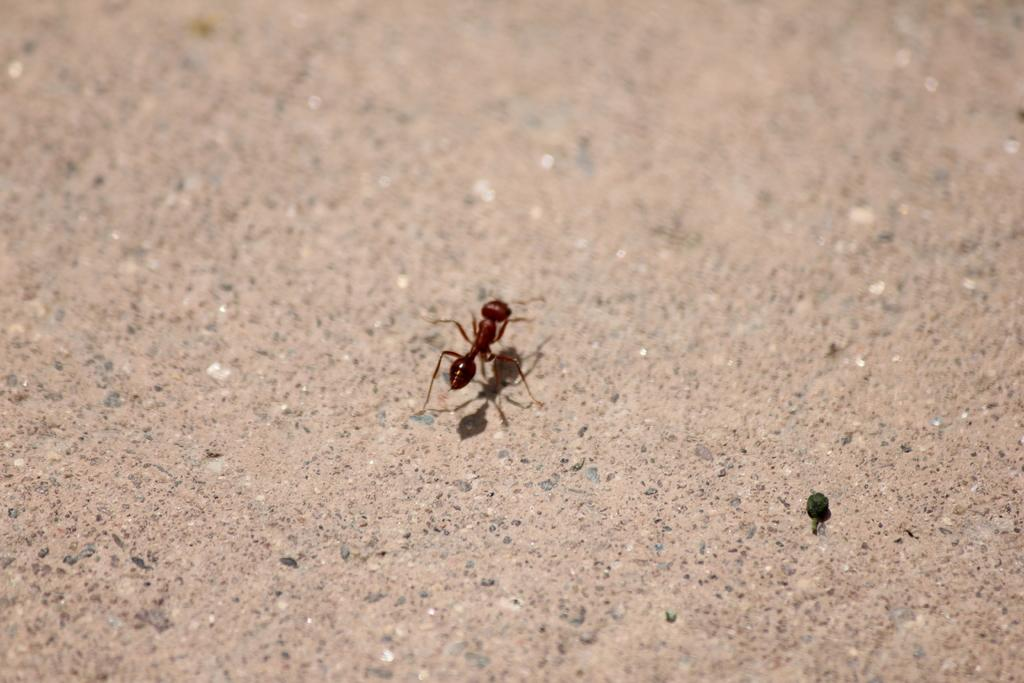What is the main subject of the image? The main subject of the image is an ant. Where is the ant located in the image? The ant is in the center of the image. What is the ant resting on or interacting with in the image? The ant is on a surface in the image. What type of border can be seen around the ant in the image? There is no border visible around the ant in the image. Can you tell me how many veins are present in the ant's body in the image? The image does not provide enough detail to count the number of veins in the ant's body. 